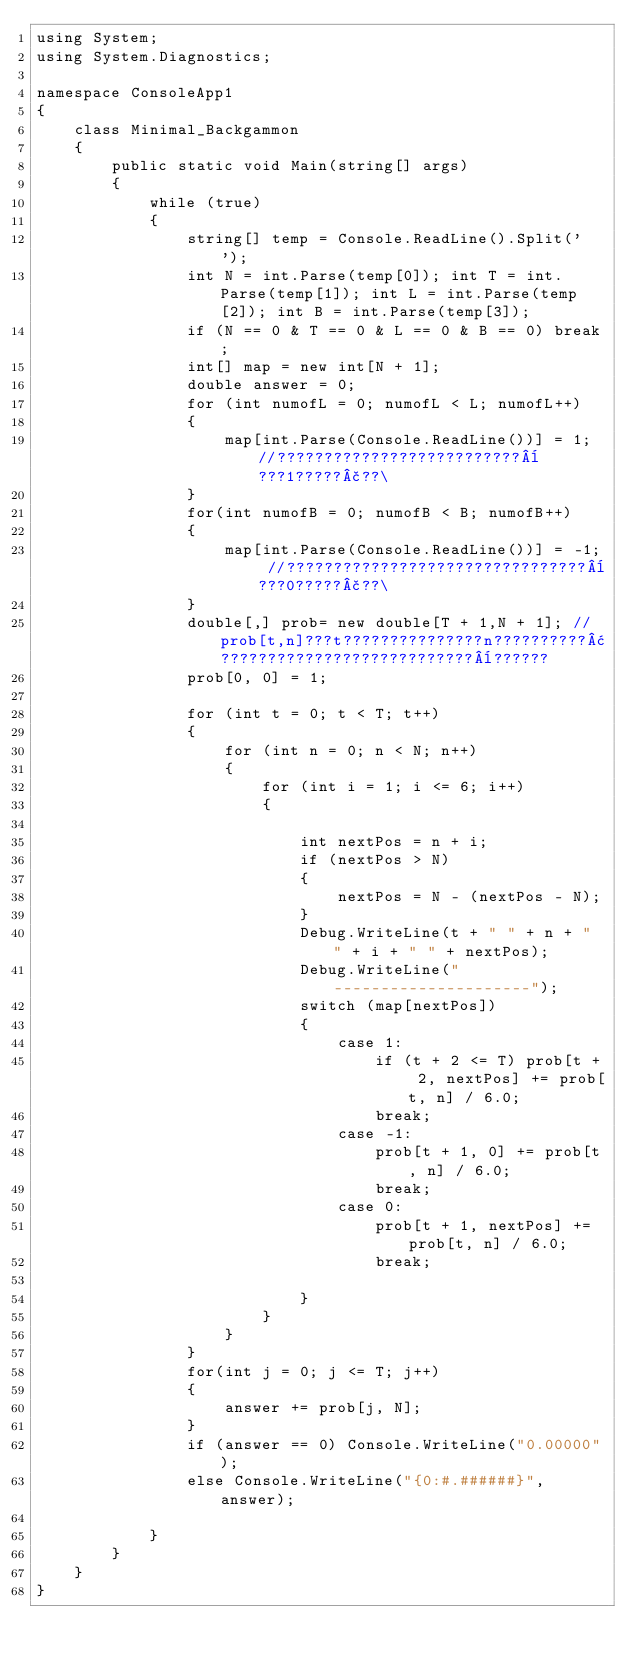<code> <loc_0><loc_0><loc_500><loc_500><_C#_>using System;
using System.Diagnostics;

namespace ConsoleApp1
{
    class Minimal_Backgammon
    {
        public static void Main(string[] args)
        {
            while (true)
            {
                string[] temp = Console.ReadLine().Split(' ');
                int N = int.Parse(temp[0]); int T = int.Parse(temp[1]); int L = int.Parse(temp[2]); int B = int.Parse(temp[3]);
                if (N == 0 & T == 0 & L == 0 & B == 0) break;
                int[] map = new int[N + 1];
                double answer = 0;
                for (int numofL = 0; numofL < L; numofL++)
                {
                    map[int.Parse(Console.ReadLine())] = 1; //??????????????????????????¨???1?????£??\
                }
                for(int numofB = 0; numofB < B; numofB++)
                {
                    map[int.Parse(Console.ReadLine())] = -1; //????????????????????????????????¨???0?????£??\
                }
                double[,] prob= new double[T + 1,N + 1]; //prob[t,n]???t???????????????n??????????¢???????????????????????????¨??????
                prob[0, 0] = 1;

                for (int t = 0; t < T; t++)
                {
                    for (int n = 0; n < N; n++)
                    {
                        for (int i = 1; i <= 6; i++)
                        {
                            
                            int nextPos = n + i;
                            if (nextPos > N)
                            {
                                nextPos = N - (nextPos - N);
                            }
                            Debug.WriteLine(t + " " + n + " " + i + " " + nextPos);
                            Debug.WriteLine("---------------------");
                            switch (map[nextPos])
                            {
                                case 1:
                                    if (t + 2 <= T) prob[t + 2, nextPos] += prob[t, n] / 6.0;
                                    break;
                                case -1:
                                    prob[t + 1, 0] += prob[t, n] / 6.0;
                                    break;
                                case 0:
                                    prob[t + 1, nextPos] += prob[t, n] / 6.0;
                                    break;

                            }
                        }
                    }
                }
                for(int j = 0; j <= T; j++)
                {
                    answer += prob[j, N];
                }
                if (answer == 0) Console.WriteLine("0.00000");
                else Console.WriteLine("{0:#.######}", answer);
                
            }
        }
    }
}</code> 